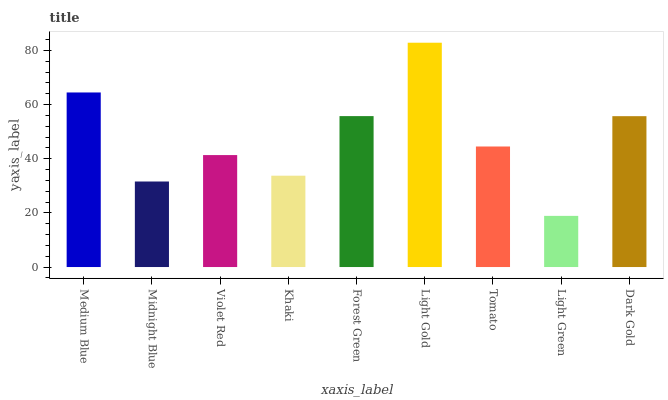Is Light Green the minimum?
Answer yes or no. Yes. Is Light Gold the maximum?
Answer yes or no. Yes. Is Midnight Blue the minimum?
Answer yes or no. No. Is Midnight Blue the maximum?
Answer yes or no. No. Is Medium Blue greater than Midnight Blue?
Answer yes or no. Yes. Is Midnight Blue less than Medium Blue?
Answer yes or no. Yes. Is Midnight Blue greater than Medium Blue?
Answer yes or no. No. Is Medium Blue less than Midnight Blue?
Answer yes or no. No. Is Tomato the high median?
Answer yes or no. Yes. Is Tomato the low median?
Answer yes or no. Yes. Is Midnight Blue the high median?
Answer yes or no. No. Is Violet Red the low median?
Answer yes or no. No. 